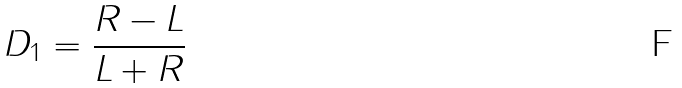<formula> <loc_0><loc_0><loc_500><loc_500>D _ { 1 } = \frac { R - L } { L + R }</formula> 